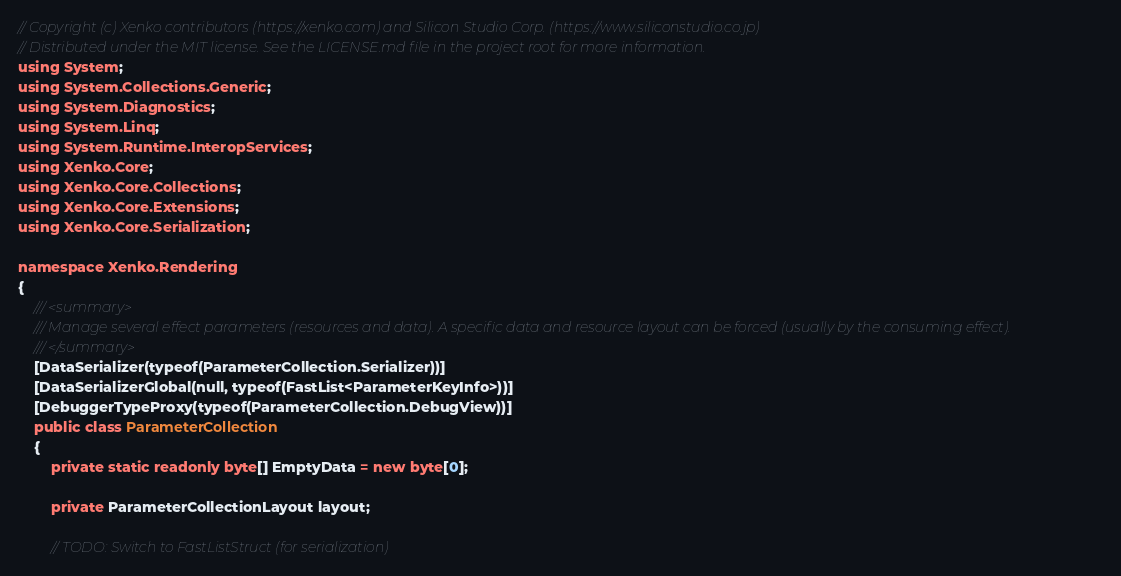Convert code to text. <code><loc_0><loc_0><loc_500><loc_500><_C#_>// Copyright (c) Xenko contributors (https://xenko.com) and Silicon Studio Corp. (https://www.siliconstudio.co.jp)
// Distributed under the MIT license. See the LICENSE.md file in the project root for more information.
using System;
using System.Collections.Generic;
using System.Diagnostics;
using System.Linq;
using System.Runtime.InteropServices;
using Xenko.Core;
using Xenko.Core.Collections;
using Xenko.Core.Extensions;
using Xenko.Core.Serialization;

namespace Xenko.Rendering
{
    /// <summary>
    /// Manage several effect parameters (resources and data). A specific data and resource layout can be forced (usually by the consuming effect).
    /// </summary>
    [DataSerializer(typeof(ParameterCollection.Serializer))]
    [DataSerializerGlobal(null, typeof(FastList<ParameterKeyInfo>))]
    [DebuggerTypeProxy(typeof(ParameterCollection.DebugView))]
    public class ParameterCollection
    {
        private static readonly byte[] EmptyData = new byte[0];

        private ParameterCollectionLayout layout;

        // TODO: Switch to FastListStruct (for serialization)</code> 